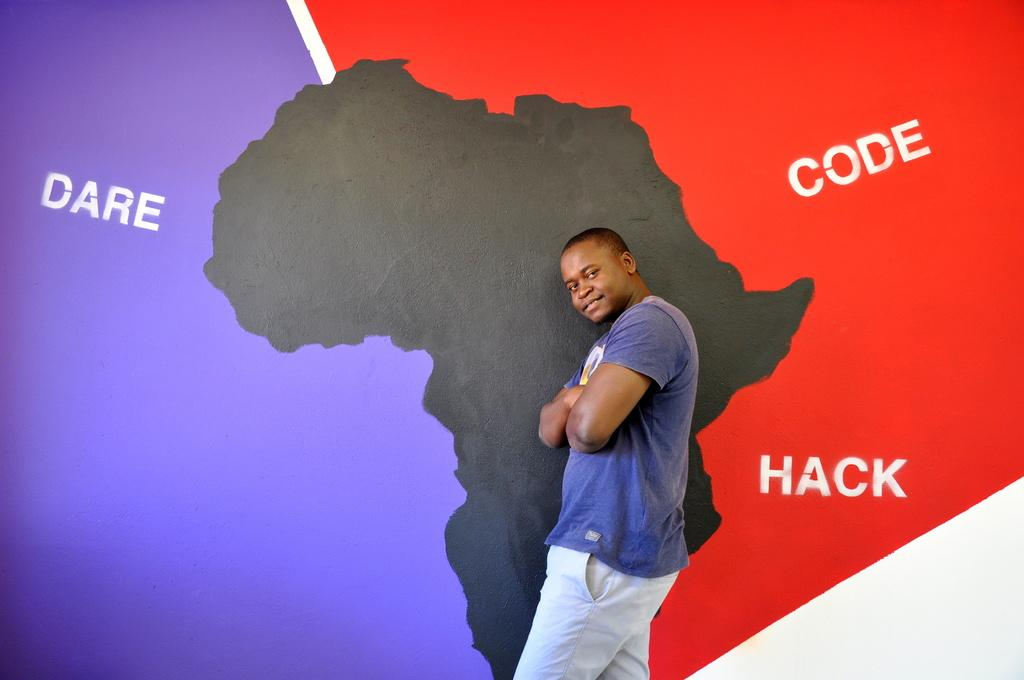<image>
Summarize the visual content of the image. Man standing in front of a wall which says Code and Hack. 